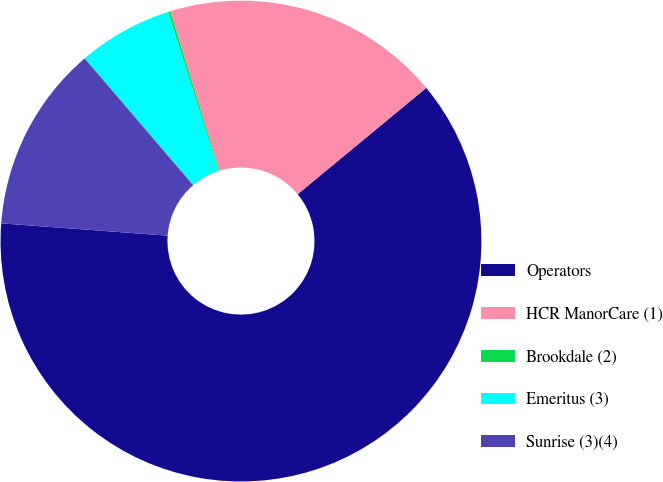Convert chart to OTSL. <chart><loc_0><loc_0><loc_500><loc_500><pie_chart><fcel>Operators<fcel>HCR ManorCare (1)<fcel>Brookdale (2)<fcel>Emeritus (3)<fcel>Sunrise (3)(4)<nl><fcel>62.17%<fcel>18.76%<fcel>0.15%<fcel>6.36%<fcel>12.56%<nl></chart> 